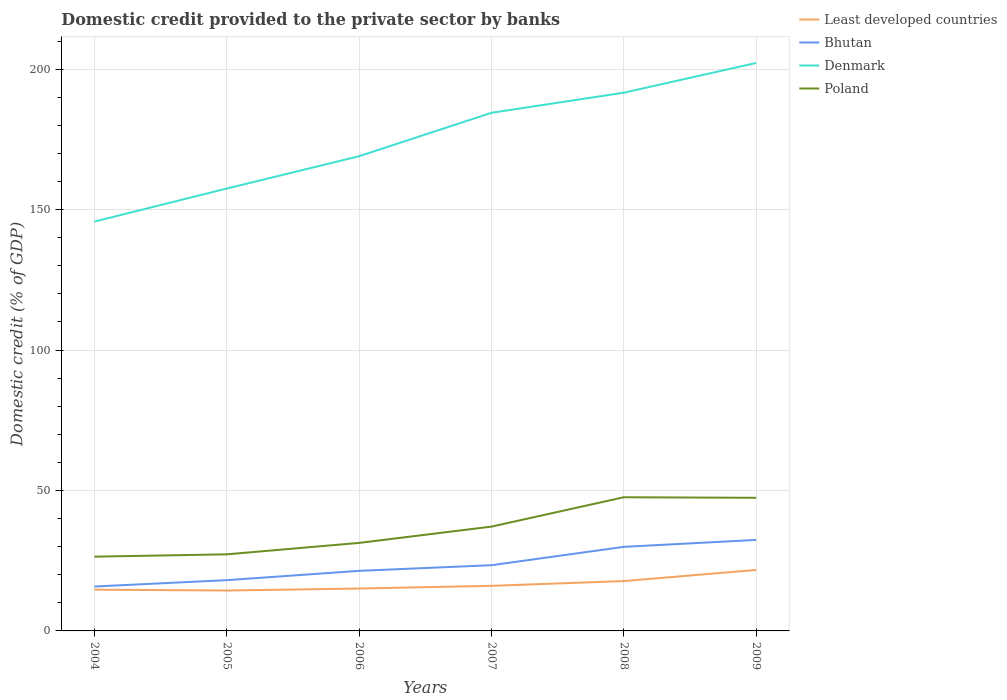Does the line corresponding to Least developed countries intersect with the line corresponding to Bhutan?
Keep it short and to the point. No. Is the number of lines equal to the number of legend labels?
Your answer should be very brief. Yes. Across all years, what is the maximum domestic credit provided to the private sector by banks in Bhutan?
Provide a succinct answer. 15.81. What is the total domestic credit provided to the private sector by banks in Poland in the graph?
Ensure brevity in your answer.  -10.25. What is the difference between the highest and the second highest domestic credit provided to the private sector by banks in Bhutan?
Keep it short and to the point. 16.58. What is the difference between the highest and the lowest domestic credit provided to the private sector by banks in Denmark?
Your answer should be compact. 3. How many years are there in the graph?
Provide a short and direct response. 6. What is the difference between two consecutive major ticks on the Y-axis?
Make the answer very short. 50. Does the graph contain any zero values?
Offer a very short reply. No. How are the legend labels stacked?
Keep it short and to the point. Vertical. What is the title of the graph?
Keep it short and to the point. Domestic credit provided to the private sector by banks. Does "Fragile and conflict affected situations" appear as one of the legend labels in the graph?
Ensure brevity in your answer.  No. What is the label or title of the X-axis?
Offer a very short reply. Years. What is the label or title of the Y-axis?
Give a very brief answer. Domestic credit (% of GDP). What is the Domestic credit (% of GDP) in Least developed countries in 2004?
Make the answer very short. 14.69. What is the Domestic credit (% of GDP) of Bhutan in 2004?
Your answer should be compact. 15.81. What is the Domestic credit (% of GDP) of Denmark in 2004?
Provide a succinct answer. 145.72. What is the Domestic credit (% of GDP) in Poland in 2004?
Offer a terse response. 26.44. What is the Domestic credit (% of GDP) in Least developed countries in 2005?
Give a very brief answer. 14.38. What is the Domestic credit (% of GDP) of Bhutan in 2005?
Your response must be concise. 18.07. What is the Domestic credit (% of GDP) in Denmark in 2005?
Provide a succinct answer. 157.49. What is the Domestic credit (% of GDP) in Poland in 2005?
Offer a very short reply. 27.27. What is the Domestic credit (% of GDP) of Least developed countries in 2006?
Your response must be concise. 15.1. What is the Domestic credit (% of GDP) in Bhutan in 2006?
Your answer should be compact. 21.39. What is the Domestic credit (% of GDP) of Denmark in 2006?
Provide a succinct answer. 169. What is the Domestic credit (% of GDP) in Poland in 2006?
Keep it short and to the point. 31.33. What is the Domestic credit (% of GDP) of Least developed countries in 2007?
Your answer should be very brief. 16.05. What is the Domestic credit (% of GDP) of Bhutan in 2007?
Keep it short and to the point. 23.4. What is the Domestic credit (% of GDP) of Denmark in 2007?
Your answer should be compact. 184.45. What is the Domestic credit (% of GDP) in Poland in 2007?
Your answer should be compact. 37.14. What is the Domestic credit (% of GDP) in Least developed countries in 2008?
Provide a succinct answer. 17.75. What is the Domestic credit (% of GDP) in Bhutan in 2008?
Keep it short and to the point. 29.93. What is the Domestic credit (% of GDP) in Denmark in 2008?
Your answer should be compact. 191.61. What is the Domestic credit (% of GDP) in Poland in 2008?
Your answer should be compact. 47.59. What is the Domestic credit (% of GDP) in Least developed countries in 2009?
Your response must be concise. 21.71. What is the Domestic credit (% of GDP) in Bhutan in 2009?
Your answer should be compact. 32.39. What is the Domestic credit (% of GDP) of Denmark in 2009?
Keep it short and to the point. 202.19. What is the Domestic credit (% of GDP) of Poland in 2009?
Your answer should be very brief. 47.39. Across all years, what is the maximum Domestic credit (% of GDP) of Least developed countries?
Offer a terse response. 21.71. Across all years, what is the maximum Domestic credit (% of GDP) in Bhutan?
Your response must be concise. 32.39. Across all years, what is the maximum Domestic credit (% of GDP) of Denmark?
Your response must be concise. 202.19. Across all years, what is the maximum Domestic credit (% of GDP) of Poland?
Give a very brief answer. 47.59. Across all years, what is the minimum Domestic credit (% of GDP) of Least developed countries?
Provide a succinct answer. 14.38. Across all years, what is the minimum Domestic credit (% of GDP) of Bhutan?
Ensure brevity in your answer.  15.81. Across all years, what is the minimum Domestic credit (% of GDP) of Denmark?
Give a very brief answer. 145.72. Across all years, what is the minimum Domestic credit (% of GDP) of Poland?
Your answer should be very brief. 26.44. What is the total Domestic credit (% of GDP) of Least developed countries in the graph?
Keep it short and to the point. 99.68. What is the total Domestic credit (% of GDP) in Bhutan in the graph?
Provide a short and direct response. 140.99. What is the total Domestic credit (% of GDP) in Denmark in the graph?
Your answer should be very brief. 1050.45. What is the total Domestic credit (% of GDP) of Poland in the graph?
Your answer should be very brief. 217.15. What is the difference between the Domestic credit (% of GDP) in Least developed countries in 2004 and that in 2005?
Make the answer very short. 0.31. What is the difference between the Domestic credit (% of GDP) in Bhutan in 2004 and that in 2005?
Provide a succinct answer. -2.26. What is the difference between the Domestic credit (% of GDP) of Denmark in 2004 and that in 2005?
Offer a terse response. -11.77. What is the difference between the Domestic credit (% of GDP) of Poland in 2004 and that in 2005?
Make the answer very short. -0.83. What is the difference between the Domestic credit (% of GDP) in Least developed countries in 2004 and that in 2006?
Your answer should be very brief. -0.41. What is the difference between the Domestic credit (% of GDP) in Bhutan in 2004 and that in 2006?
Your answer should be very brief. -5.57. What is the difference between the Domestic credit (% of GDP) in Denmark in 2004 and that in 2006?
Offer a very short reply. -23.28. What is the difference between the Domestic credit (% of GDP) in Poland in 2004 and that in 2006?
Offer a terse response. -4.9. What is the difference between the Domestic credit (% of GDP) of Least developed countries in 2004 and that in 2007?
Provide a succinct answer. -1.36. What is the difference between the Domestic credit (% of GDP) of Bhutan in 2004 and that in 2007?
Your answer should be very brief. -7.58. What is the difference between the Domestic credit (% of GDP) of Denmark in 2004 and that in 2007?
Your response must be concise. -38.73. What is the difference between the Domestic credit (% of GDP) in Poland in 2004 and that in 2007?
Provide a succinct answer. -10.7. What is the difference between the Domestic credit (% of GDP) in Least developed countries in 2004 and that in 2008?
Your response must be concise. -3.05. What is the difference between the Domestic credit (% of GDP) in Bhutan in 2004 and that in 2008?
Make the answer very short. -14.12. What is the difference between the Domestic credit (% of GDP) of Denmark in 2004 and that in 2008?
Ensure brevity in your answer.  -45.88. What is the difference between the Domestic credit (% of GDP) in Poland in 2004 and that in 2008?
Keep it short and to the point. -21.15. What is the difference between the Domestic credit (% of GDP) of Least developed countries in 2004 and that in 2009?
Give a very brief answer. -7.02. What is the difference between the Domestic credit (% of GDP) in Bhutan in 2004 and that in 2009?
Keep it short and to the point. -16.58. What is the difference between the Domestic credit (% of GDP) in Denmark in 2004 and that in 2009?
Provide a short and direct response. -56.47. What is the difference between the Domestic credit (% of GDP) of Poland in 2004 and that in 2009?
Offer a terse response. -20.95. What is the difference between the Domestic credit (% of GDP) of Least developed countries in 2005 and that in 2006?
Your response must be concise. -0.71. What is the difference between the Domestic credit (% of GDP) in Bhutan in 2005 and that in 2006?
Your response must be concise. -3.32. What is the difference between the Domestic credit (% of GDP) in Denmark in 2005 and that in 2006?
Provide a succinct answer. -11.51. What is the difference between the Domestic credit (% of GDP) in Poland in 2005 and that in 2006?
Give a very brief answer. -4.07. What is the difference between the Domestic credit (% of GDP) in Least developed countries in 2005 and that in 2007?
Ensure brevity in your answer.  -1.67. What is the difference between the Domestic credit (% of GDP) in Bhutan in 2005 and that in 2007?
Provide a succinct answer. -5.33. What is the difference between the Domestic credit (% of GDP) of Denmark in 2005 and that in 2007?
Keep it short and to the point. -26.96. What is the difference between the Domestic credit (% of GDP) of Poland in 2005 and that in 2007?
Ensure brevity in your answer.  -9.87. What is the difference between the Domestic credit (% of GDP) in Least developed countries in 2005 and that in 2008?
Give a very brief answer. -3.36. What is the difference between the Domestic credit (% of GDP) of Bhutan in 2005 and that in 2008?
Make the answer very short. -11.86. What is the difference between the Domestic credit (% of GDP) of Denmark in 2005 and that in 2008?
Provide a succinct answer. -34.12. What is the difference between the Domestic credit (% of GDP) of Poland in 2005 and that in 2008?
Your response must be concise. -20.32. What is the difference between the Domestic credit (% of GDP) in Least developed countries in 2005 and that in 2009?
Offer a very short reply. -7.33. What is the difference between the Domestic credit (% of GDP) of Bhutan in 2005 and that in 2009?
Give a very brief answer. -14.33. What is the difference between the Domestic credit (% of GDP) of Denmark in 2005 and that in 2009?
Your response must be concise. -44.7. What is the difference between the Domestic credit (% of GDP) in Poland in 2005 and that in 2009?
Keep it short and to the point. -20.12. What is the difference between the Domestic credit (% of GDP) of Least developed countries in 2006 and that in 2007?
Your response must be concise. -0.95. What is the difference between the Domestic credit (% of GDP) in Bhutan in 2006 and that in 2007?
Provide a succinct answer. -2.01. What is the difference between the Domestic credit (% of GDP) of Denmark in 2006 and that in 2007?
Offer a terse response. -15.45. What is the difference between the Domestic credit (% of GDP) of Poland in 2006 and that in 2007?
Provide a short and direct response. -5.8. What is the difference between the Domestic credit (% of GDP) of Least developed countries in 2006 and that in 2008?
Keep it short and to the point. -2.65. What is the difference between the Domestic credit (% of GDP) in Bhutan in 2006 and that in 2008?
Your response must be concise. -8.55. What is the difference between the Domestic credit (% of GDP) of Denmark in 2006 and that in 2008?
Ensure brevity in your answer.  -22.61. What is the difference between the Domestic credit (% of GDP) in Poland in 2006 and that in 2008?
Ensure brevity in your answer.  -16.25. What is the difference between the Domestic credit (% of GDP) in Least developed countries in 2006 and that in 2009?
Keep it short and to the point. -6.61. What is the difference between the Domestic credit (% of GDP) of Bhutan in 2006 and that in 2009?
Provide a succinct answer. -11.01. What is the difference between the Domestic credit (% of GDP) of Denmark in 2006 and that in 2009?
Your response must be concise. -33.19. What is the difference between the Domestic credit (% of GDP) in Poland in 2006 and that in 2009?
Provide a short and direct response. -16.05. What is the difference between the Domestic credit (% of GDP) in Least developed countries in 2007 and that in 2008?
Provide a succinct answer. -1.7. What is the difference between the Domestic credit (% of GDP) of Bhutan in 2007 and that in 2008?
Offer a terse response. -6.53. What is the difference between the Domestic credit (% of GDP) in Denmark in 2007 and that in 2008?
Provide a short and direct response. -7.16. What is the difference between the Domestic credit (% of GDP) in Poland in 2007 and that in 2008?
Your answer should be compact. -10.45. What is the difference between the Domestic credit (% of GDP) of Least developed countries in 2007 and that in 2009?
Keep it short and to the point. -5.66. What is the difference between the Domestic credit (% of GDP) of Bhutan in 2007 and that in 2009?
Keep it short and to the point. -9. What is the difference between the Domestic credit (% of GDP) in Denmark in 2007 and that in 2009?
Provide a short and direct response. -17.74. What is the difference between the Domestic credit (% of GDP) of Poland in 2007 and that in 2009?
Give a very brief answer. -10.25. What is the difference between the Domestic credit (% of GDP) in Least developed countries in 2008 and that in 2009?
Provide a short and direct response. -3.96. What is the difference between the Domestic credit (% of GDP) of Bhutan in 2008 and that in 2009?
Your response must be concise. -2.46. What is the difference between the Domestic credit (% of GDP) of Denmark in 2008 and that in 2009?
Provide a succinct answer. -10.58. What is the difference between the Domestic credit (% of GDP) of Poland in 2008 and that in 2009?
Keep it short and to the point. 0.2. What is the difference between the Domestic credit (% of GDP) of Least developed countries in 2004 and the Domestic credit (% of GDP) of Bhutan in 2005?
Your answer should be compact. -3.38. What is the difference between the Domestic credit (% of GDP) of Least developed countries in 2004 and the Domestic credit (% of GDP) of Denmark in 2005?
Offer a very short reply. -142.8. What is the difference between the Domestic credit (% of GDP) of Least developed countries in 2004 and the Domestic credit (% of GDP) of Poland in 2005?
Your answer should be very brief. -12.57. What is the difference between the Domestic credit (% of GDP) in Bhutan in 2004 and the Domestic credit (% of GDP) in Denmark in 2005?
Offer a terse response. -141.68. What is the difference between the Domestic credit (% of GDP) in Bhutan in 2004 and the Domestic credit (% of GDP) in Poland in 2005?
Your response must be concise. -11.45. What is the difference between the Domestic credit (% of GDP) in Denmark in 2004 and the Domestic credit (% of GDP) in Poland in 2005?
Your response must be concise. 118.46. What is the difference between the Domestic credit (% of GDP) in Least developed countries in 2004 and the Domestic credit (% of GDP) in Bhutan in 2006?
Make the answer very short. -6.69. What is the difference between the Domestic credit (% of GDP) in Least developed countries in 2004 and the Domestic credit (% of GDP) in Denmark in 2006?
Provide a short and direct response. -154.31. What is the difference between the Domestic credit (% of GDP) in Least developed countries in 2004 and the Domestic credit (% of GDP) in Poland in 2006?
Your answer should be compact. -16.64. What is the difference between the Domestic credit (% of GDP) in Bhutan in 2004 and the Domestic credit (% of GDP) in Denmark in 2006?
Ensure brevity in your answer.  -153.19. What is the difference between the Domestic credit (% of GDP) of Bhutan in 2004 and the Domestic credit (% of GDP) of Poland in 2006?
Provide a succinct answer. -15.52. What is the difference between the Domestic credit (% of GDP) of Denmark in 2004 and the Domestic credit (% of GDP) of Poland in 2006?
Your response must be concise. 114.39. What is the difference between the Domestic credit (% of GDP) in Least developed countries in 2004 and the Domestic credit (% of GDP) in Bhutan in 2007?
Provide a succinct answer. -8.71. What is the difference between the Domestic credit (% of GDP) of Least developed countries in 2004 and the Domestic credit (% of GDP) of Denmark in 2007?
Provide a short and direct response. -169.76. What is the difference between the Domestic credit (% of GDP) of Least developed countries in 2004 and the Domestic credit (% of GDP) of Poland in 2007?
Keep it short and to the point. -22.45. What is the difference between the Domestic credit (% of GDP) in Bhutan in 2004 and the Domestic credit (% of GDP) in Denmark in 2007?
Ensure brevity in your answer.  -168.63. What is the difference between the Domestic credit (% of GDP) in Bhutan in 2004 and the Domestic credit (% of GDP) in Poland in 2007?
Offer a terse response. -21.32. What is the difference between the Domestic credit (% of GDP) of Denmark in 2004 and the Domestic credit (% of GDP) of Poland in 2007?
Keep it short and to the point. 108.58. What is the difference between the Domestic credit (% of GDP) of Least developed countries in 2004 and the Domestic credit (% of GDP) of Bhutan in 2008?
Make the answer very short. -15.24. What is the difference between the Domestic credit (% of GDP) of Least developed countries in 2004 and the Domestic credit (% of GDP) of Denmark in 2008?
Your answer should be very brief. -176.91. What is the difference between the Domestic credit (% of GDP) in Least developed countries in 2004 and the Domestic credit (% of GDP) in Poland in 2008?
Offer a very short reply. -32.9. What is the difference between the Domestic credit (% of GDP) of Bhutan in 2004 and the Domestic credit (% of GDP) of Denmark in 2008?
Your response must be concise. -175.79. What is the difference between the Domestic credit (% of GDP) of Bhutan in 2004 and the Domestic credit (% of GDP) of Poland in 2008?
Keep it short and to the point. -31.77. What is the difference between the Domestic credit (% of GDP) in Denmark in 2004 and the Domestic credit (% of GDP) in Poland in 2008?
Offer a very short reply. 98.13. What is the difference between the Domestic credit (% of GDP) in Least developed countries in 2004 and the Domestic credit (% of GDP) in Bhutan in 2009?
Ensure brevity in your answer.  -17.7. What is the difference between the Domestic credit (% of GDP) in Least developed countries in 2004 and the Domestic credit (% of GDP) in Denmark in 2009?
Offer a terse response. -187.5. What is the difference between the Domestic credit (% of GDP) of Least developed countries in 2004 and the Domestic credit (% of GDP) of Poland in 2009?
Ensure brevity in your answer.  -32.7. What is the difference between the Domestic credit (% of GDP) of Bhutan in 2004 and the Domestic credit (% of GDP) of Denmark in 2009?
Your answer should be very brief. -186.38. What is the difference between the Domestic credit (% of GDP) in Bhutan in 2004 and the Domestic credit (% of GDP) in Poland in 2009?
Offer a terse response. -31.58. What is the difference between the Domestic credit (% of GDP) of Denmark in 2004 and the Domestic credit (% of GDP) of Poland in 2009?
Make the answer very short. 98.33. What is the difference between the Domestic credit (% of GDP) of Least developed countries in 2005 and the Domestic credit (% of GDP) of Bhutan in 2006?
Your answer should be compact. -7. What is the difference between the Domestic credit (% of GDP) in Least developed countries in 2005 and the Domestic credit (% of GDP) in Denmark in 2006?
Offer a terse response. -154.62. What is the difference between the Domestic credit (% of GDP) of Least developed countries in 2005 and the Domestic credit (% of GDP) of Poland in 2006?
Give a very brief answer. -16.95. What is the difference between the Domestic credit (% of GDP) in Bhutan in 2005 and the Domestic credit (% of GDP) in Denmark in 2006?
Your answer should be compact. -150.93. What is the difference between the Domestic credit (% of GDP) of Bhutan in 2005 and the Domestic credit (% of GDP) of Poland in 2006?
Keep it short and to the point. -13.27. What is the difference between the Domestic credit (% of GDP) of Denmark in 2005 and the Domestic credit (% of GDP) of Poland in 2006?
Keep it short and to the point. 126.15. What is the difference between the Domestic credit (% of GDP) of Least developed countries in 2005 and the Domestic credit (% of GDP) of Bhutan in 2007?
Your answer should be compact. -9.01. What is the difference between the Domestic credit (% of GDP) in Least developed countries in 2005 and the Domestic credit (% of GDP) in Denmark in 2007?
Your answer should be compact. -170.06. What is the difference between the Domestic credit (% of GDP) in Least developed countries in 2005 and the Domestic credit (% of GDP) in Poland in 2007?
Your answer should be compact. -22.75. What is the difference between the Domestic credit (% of GDP) in Bhutan in 2005 and the Domestic credit (% of GDP) in Denmark in 2007?
Give a very brief answer. -166.38. What is the difference between the Domestic credit (% of GDP) of Bhutan in 2005 and the Domestic credit (% of GDP) of Poland in 2007?
Your answer should be compact. -19.07. What is the difference between the Domestic credit (% of GDP) of Denmark in 2005 and the Domestic credit (% of GDP) of Poland in 2007?
Your response must be concise. 120.35. What is the difference between the Domestic credit (% of GDP) in Least developed countries in 2005 and the Domestic credit (% of GDP) in Bhutan in 2008?
Provide a short and direct response. -15.55. What is the difference between the Domestic credit (% of GDP) in Least developed countries in 2005 and the Domestic credit (% of GDP) in Denmark in 2008?
Your response must be concise. -177.22. What is the difference between the Domestic credit (% of GDP) in Least developed countries in 2005 and the Domestic credit (% of GDP) in Poland in 2008?
Offer a terse response. -33.2. What is the difference between the Domestic credit (% of GDP) of Bhutan in 2005 and the Domestic credit (% of GDP) of Denmark in 2008?
Make the answer very short. -173.54. What is the difference between the Domestic credit (% of GDP) in Bhutan in 2005 and the Domestic credit (% of GDP) in Poland in 2008?
Offer a terse response. -29.52. What is the difference between the Domestic credit (% of GDP) in Denmark in 2005 and the Domestic credit (% of GDP) in Poland in 2008?
Your response must be concise. 109.9. What is the difference between the Domestic credit (% of GDP) in Least developed countries in 2005 and the Domestic credit (% of GDP) in Bhutan in 2009?
Give a very brief answer. -18.01. What is the difference between the Domestic credit (% of GDP) in Least developed countries in 2005 and the Domestic credit (% of GDP) in Denmark in 2009?
Ensure brevity in your answer.  -187.81. What is the difference between the Domestic credit (% of GDP) of Least developed countries in 2005 and the Domestic credit (% of GDP) of Poland in 2009?
Offer a terse response. -33. What is the difference between the Domestic credit (% of GDP) of Bhutan in 2005 and the Domestic credit (% of GDP) of Denmark in 2009?
Make the answer very short. -184.12. What is the difference between the Domestic credit (% of GDP) of Bhutan in 2005 and the Domestic credit (% of GDP) of Poland in 2009?
Your answer should be very brief. -29.32. What is the difference between the Domestic credit (% of GDP) in Denmark in 2005 and the Domestic credit (% of GDP) in Poland in 2009?
Ensure brevity in your answer.  110.1. What is the difference between the Domestic credit (% of GDP) in Least developed countries in 2006 and the Domestic credit (% of GDP) in Bhutan in 2007?
Your answer should be very brief. -8.3. What is the difference between the Domestic credit (% of GDP) in Least developed countries in 2006 and the Domestic credit (% of GDP) in Denmark in 2007?
Your response must be concise. -169.35. What is the difference between the Domestic credit (% of GDP) of Least developed countries in 2006 and the Domestic credit (% of GDP) of Poland in 2007?
Provide a short and direct response. -22.04. What is the difference between the Domestic credit (% of GDP) in Bhutan in 2006 and the Domestic credit (% of GDP) in Denmark in 2007?
Offer a terse response. -163.06. What is the difference between the Domestic credit (% of GDP) in Bhutan in 2006 and the Domestic credit (% of GDP) in Poland in 2007?
Ensure brevity in your answer.  -15.75. What is the difference between the Domestic credit (% of GDP) in Denmark in 2006 and the Domestic credit (% of GDP) in Poland in 2007?
Provide a succinct answer. 131.86. What is the difference between the Domestic credit (% of GDP) in Least developed countries in 2006 and the Domestic credit (% of GDP) in Bhutan in 2008?
Your answer should be very brief. -14.83. What is the difference between the Domestic credit (% of GDP) in Least developed countries in 2006 and the Domestic credit (% of GDP) in Denmark in 2008?
Offer a very short reply. -176.51. What is the difference between the Domestic credit (% of GDP) in Least developed countries in 2006 and the Domestic credit (% of GDP) in Poland in 2008?
Offer a very short reply. -32.49. What is the difference between the Domestic credit (% of GDP) in Bhutan in 2006 and the Domestic credit (% of GDP) in Denmark in 2008?
Keep it short and to the point. -170.22. What is the difference between the Domestic credit (% of GDP) of Bhutan in 2006 and the Domestic credit (% of GDP) of Poland in 2008?
Your answer should be very brief. -26.2. What is the difference between the Domestic credit (% of GDP) of Denmark in 2006 and the Domestic credit (% of GDP) of Poland in 2008?
Provide a succinct answer. 121.41. What is the difference between the Domestic credit (% of GDP) in Least developed countries in 2006 and the Domestic credit (% of GDP) in Bhutan in 2009?
Offer a very short reply. -17.3. What is the difference between the Domestic credit (% of GDP) in Least developed countries in 2006 and the Domestic credit (% of GDP) in Denmark in 2009?
Make the answer very short. -187.09. What is the difference between the Domestic credit (% of GDP) of Least developed countries in 2006 and the Domestic credit (% of GDP) of Poland in 2009?
Offer a terse response. -32.29. What is the difference between the Domestic credit (% of GDP) of Bhutan in 2006 and the Domestic credit (% of GDP) of Denmark in 2009?
Provide a short and direct response. -180.8. What is the difference between the Domestic credit (% of GDP) of Bhutan in 2006 and the Domestic credit (% of GDP) of Poland in 2009?
Give a very brief answer. -26. What is the difference between the Domestic credit (% of GDP) of Denmark in 2006 and the Domestic credit (% of GDP) of Poland in 2009?
Provide a short and direct response. 121.61. What is the difference between the Domestic credit (% of GDP) in Least developed countries in 2007 and the Domestic credit (% of GDP) in Bhutan in 2008?
Offer a terse response. -13.88. What is the difference between the Domestic credit (% of GDP) of Least developed countries in 2007 and the Domestic credit (% of GDP) of Denmark in 2008?
Ensure brevity in your answer.  -175.56. What is the difference between the Domestic credit (% of GDP) of Least developed countries in 2007 and the Domestic credit (% of GDP) of Poland in 2008?
Offer a terse response. -31.54. What is the difference between the Domestic credit (% of GDP) in Bhutan in 2007 and the Domestic credit (% of GDP) in Denmark in 2008?
Provide a short and direct response. -168.21. What is the difference between the Domestic credit (% of GDP) in Bhutan in 2007 and the Domestic credit (% of GDP) in Poland in 2008?
Provide a succinct answer. -24.19. What is the difference between the Domestic credit (% of GDP) of Denmark in 2007 and the Domestic credit (% of GDP) of Poland in 2008?
Your answer should be very brief. 136.86. What is the difference between the Domestic credit (% of GDP) in Least developed countries in 2007 and the Domestic credit (% of GDP) in Bhutan in 2009?
Provide a succinct answer. -16.34. What is the difference between the Domestic credit (% of GDP) of Least developed countries in 2007 and the Domestic credit (% of GDP) of Denmark in 2009?
Provide a short and direct response. -186.14. What is the difference between the Domestic credit (% of GDP) of Least developed countries in 2007 and the Domestic credit (% of GDP) of Poland in 2009?
Keep it short and to the point. -31.34. What is the difference between the Domestic credit (% of GDP) in Bhutan in 2007 and the Domestic credit (% of GDP) in Denmark in 2009?
Give a very brief answer. -178.79. What is the difference between the Domestic credit (% of GDP) of Bhutan in 2007 and the Domestic credit (% of GDP) of Poland in 2009?
Your answer should be very brief. -23.99. What is the difference between the Domestic credit (% of GDP) of Denmark in 2007 and the Domestic credit (% of GDP) of Poland in 2009?
Provide a succinct answer. 137.06. What is the difference between the Domestic credit (% of GDP) in Least developed countries in 2008 and the Domestic credit (% of GDP) in Bhutan in 2009?
Provide a succinct answer. -14.65. What is the difference between the Domestic credit (% of GDP) of Least developed countries in 2008 and the Domestic credit (% of GDP) of Denmark in 2009?
Keep it short and to the point. -184.44. What is the difference between the Domestic credit (% of GDP) in Least developed countries in 2008 and the Domestic credit (% of GDP) in Poland in 2009?
Make the answer very short. -29.64. What is the difference between the Domestic credit (% of GDP) in Bhutan in 2008 and the Domestic credit (% of GDP) in Denmark in 2009?
Ensure brevity in your answer.  -172.26. What is the difference between the Domestic credit (% of GDP) of Bhutan in 2008 and the Domestic credit (% of GDP) of Poland in 2009?
Ensure brevity in your answer.  -17.46. What is the difference between the Domestic credit (% of GDP) of Denmark in 2008 and the Domestic credit (% of GDP) of Poland in 2009?
Your answer should be compact. 144.22. What is the average Domestic credit (% of GDP) in Least developed countries per year?
Your answer should be compact. 16.61. What is the average Domestic credit (% of GDP) of Bhutan per year?
Give a very brief answer. 23.5. What is the average Domestic credit (% of GDP) of Denmark per year?
Make the answer very short. 175.08. What is the average Domestic credit (% of GDP) of Poland per year?
Ensure brevity in your answer.  36.19. In the year 2004, what is the difference between the Domestic credit (% of GDP) in Least developed countries and Domestic credit (% of GDP) in Bhutan?
Ensure brevity in your answer.  -1.12. In the year 2004, what is the difference between the Domestic credit (% of GDP) of Least developed countries and Domestic credit (% of GDP) of Denmark?
Give a very brief answer. -131.03. In the year 2004, what is the difference between the Domestic credit (% of GDP) of Least developed countries and Domestic credit (% of GDP) of Poland?
Your answer should be compact. -11.75. In the year 2004, what is the difference between the Domestic credit (% of GDP) of Bhutan and Domestic credit (% of GDP) of Denmark?
Your response must be concise. -129.91. In the year 2004, what is the difference between the Domestic credit (% of GDP) of Bhutan and Domestic credit (% of GDP) of Poland?
Make the answer very short. -10.62. In the year 2004, what is the difference between the Domestic credit (% of GDP) of Denmark and Domestic credit (% of GDP) of Poland?
Your answer should be compact. 119.29. In the year 2005, what is the difference between the Domestic credit (% of GDP) in Least developed countries and Domestic credit (% of GDP) in Bhutan?
Provide a short and direct response. -3.69. In the year 2005, what is the difference between the Domestic credit (% of GDP) of Least developed countries and Domestic credit (% of GDP) of Denmark?
Offer a very short reply. -143.11. In the year 2005, what is the difference between the Domestic credit (% of GDP) of Least developed countries and Domestic credit (% of GDP) of Poland?
Provide a short and direct response. -12.88. In the year 2005, what is the difference between the Domestic credit (% of GDP) of Bhutan and Domestic credit (% of GDP) of Denmark?
Your answer should be compact. -139.42. In the year 2005, what is the difference between the Domestic credit (% of GDP) of Bhutan and Domestic credit (% of GDP) of Poland?
Your answer should be very brief. -9.2. In the year 2005, what is the difference between the Domestic credit (% of GDP) in Denmark and Domestic credit (% of GDP) in Poland?
Your answer should be compact. 130.22. In the year 2006, what is the difference between the Domestic credit (% of GDP) of Least developed countries and Domestic credit (% of GDP) of Bhutan?
Offer a very short reply. -6.29. In the year 2006, what is the difference between the Domestic credit (% of GDP) of Least developed countries and Domestic credit (% of GDP) of Denmark?
Offer a terse response. -153.9. In the year 2006, what is the difference between the Domestic credit (% of GDP) of Least developed countries and Domestic credit (% of GDP) of Poland?
Keep it short and to the point. -16.24. In the year 2006, what is the difference between the Domestic credit (% of GDP) in Bhutan and Domestic credit (% of GDP) in Denmark?
Give a very brief answer. -147.61. In the year 2006, what is the difference between the Domestic credit (% of GDP) of Bhutan and Domestic credit (% of GDP) of Poland?
Keep it short and to the point. -9.95. In the year 2006, what is the difference between the Domestic credit (% of GDP) of Denmark and Domestic credit (% of GDP) of Poland?
Keep it short and to the point. 137.66. In the year 2007, what is the difference between the Domestic credit (% of GDP) in Least developed countries and Domestic credit (% of GDP) in Bhutan?
Offer a terse response. -7.35. In the year 2007, what is the difference between the Domestic credit (% of GDP) of Least developed countries and Domestic credit (% of GDP) of Denmark?
Offer a terse response. -168.4. In the year 2007, what is the difference between the Domestic credit (% of GDP) in Least developed countries and Domestic credit (% of GDP) in Poland?
Ensure brevity in your answer.  -21.09. In the year 2007, what is the difference between the Domestic credit (% of GDP) of Bhutan and Domestic credit (% of GDP) of Denmark?
Offer a terse response. -161.05. In the year 2007, what is the difference between the Domestic credit (% of GDP) in Bhutan and Domestic credit (% of GDP) in Poland?
Provide a short and direct response. -13.74. In the year 2007, what is the difference between the Domestic credit (% of GDP) in Denmark and Domestic credit (% of GDP) in Poland?
Your answer should be very brief. 147.31. In the year 2008, what is the difference between the Domestic credit (% of GDP) of Least developed countries and Domestic credit (% of GDP) of Bhutan?
Provide a short and direct response. -12.19. In the year 2008, what is the difference between the Domestic credit (% of GDP) of Least developed countries and Domestic credit (% of GDP) of Denmark?
Your answer should be very brief. -173.86. In the year 2008, what is the difference between the Domestic credit (% of GDP) in Least developed countries and Domestic credit (% of GDP) in Poland?
Your answer should be very brief. -29.84. In the year 2008, what is the difference between the Domestic credit (% of GDP) in Bhutan and Domestic credit (% of GDP) in Denmark?
Provide a succinct answer. -161.68. In the year 2008, what is the difference between the Domestic credit (% of GDP) of Bhutan and Domestic credit (% of GDP) of Poland?
Provide a short and direct response. -17.66. In the year 2008, what is the difference between the Domestic credit (% of GDP) in Denmark and Domestic credit (% of GDP) in Poland?
Your response must be concise. 144.02. In the year 2009, what is the difference between the Domestic credit (% of GDP) in Least developed countries and Domestic credit (% of GDP) in Bhutan?
Keep it short and to the point. -10.68. In the year 2009, what is the difference between the Domestic credit (% of GDP) in Least developed countries and Domestic credit (% of GDP) in Denmark?
Provide a short and direct response. -180.48. In the year 2009, what is the difference between the Domestic credit (% of GDP) of Least developed countries and Domestic credit (% of GDP) of Poland?
Offer a very short reply. -25.68. In the year 2009, what is the difference between the Domestic credit (% of GDP) in Bhutan and Domestic credit (% of GDP) in Denmark?
Your response must be concise. -169.79. In the year 2009, what is the difference between the Domestic credit (% of GDP) in Bhutan and Domestic credit (% of GDP) in Poland?
Offer a very short reply. -14.99. In the year 2009, what is the difference between the Domestic credit (% of GDP) of Denmark and Domestic credit (% of GDP) of Poland?
Your response must be concise. 154.8. What is the ratio of the Domestic credit (% of GDP) of Least developed countries in 2004 to that in 2005?
Offer a terse response. 1.02. What is the ratio of the Domestic credit (% of GDP) in Bhutan in 2004 to that in 2005?
Your answer should be very brief. 0.88. What is the ratio of the Domestic credit (% of GDP) of Denmark in 2004 to that in 2005?
Offer a terse response. 0.93. What is the ratio of the Domestic credit (% of GDP) in Poland in 2004 to that in 2005?
Provide a short and direct response. 0.97. What is the ratio of the Domestic credit (% of GDP) of Least developed countries in 2004 to that in 2006?
Your answer should be compact. 0.97. What is the ratio of the Domestic credit (% of GDP) of Bhutan in 2004 to that in 2006?
Your answer should be very brief. 0.74. What is the ratio of the Domestic credit (% of GDP) of Denmark in 2004 to that in 2006?
Provide a short and direct response. 0.86. What is the ratio of the Domestic credit (% of GDP) in Poland in 2004 to that in 2006?
Your response must be concise. 0.84. What is the ratio of the Domestic credit (% of GDP) of Least developed countries in 2004 to that in 2007?
Offer a terse response. 0.92. What is the ratio of the Domestic credit (% of GDP) in Bhutan in 2004 to that in 2007?
Your answer should be very brief. 0.68. What is the ratio of the Domestic credit (% of GDP) of Denmark in 2004 to that in 2007?
Provide a succinct answer. 0.79. What is the ratio of the Domestic credit (% of GDP) in Poland in 2004 to that in 2007?
Ensure brevity in your answer.  0.71. What is the ratio of the Domestic credit (% of GDP) in Least developed countries in 2004 to that in 2008?
Keep it short and to the point. 0.83. What is the ratio of the Domestic credit (% of GDP) of Bhutan in 2004 to that in 2008?
Provide a succinct answer. 0.53. What is the ratio of the Domestic credit (% of GDP) in Denmark in 2004 to that in 2008?
Your response must be concise. 0.76. What is the ratio of the Domestic credit (% of GDP) of Poland in 2004 to that in 2008?
Provide a succinct answer. 0.56. What is the ratio of the Domestic credit (% of GDP) in Least developed countries in 2004 to that in 2009?
Provide a short and direct response. 0.68. What is the ratio of the Domestic credit (% of GDP) of Bhutan in 2004 to that in 2009?
Give a very brief answer. 0.49. What is the ratio of the Domestic credit (% of GDP) in Denmark in 2004 to that in 2009?
Ensure brevity in your answer.  0.72. What is the ratio of the Domestic credit (% of GDP) in Poland in 2004 to that in 2009?
Your response must be concise. 0.56. What is the ratio of the Domestic credit (% of GDP) of Least developed countries in 2005 to that in 2006?
Make the answer very short. 0.95. What is the ratio of the Domestic credit (% of GDP) in Bhutan in 2005 to that in 2006?
Provide a short and direct response. 0.84. What is the ratio of the Domestic credit (% of GDP) of Denmark in 2005 to that in 2006?
Provide a short and direct response. 0.93. What is the ratio of the Domestic credit (% of GDP) of Poland in 2005 to that in 2006?
Provide a succinct answer. 0.87. What is the ratio of the Domestic credit (% of GDP) in Least developed countries in 2005 to that in 2007?
Provide a short and direct response. 0.9. What is the ratio of the Domestic credit (% of GDP) in Bhutan in 2005 to that in 2007?
Your answer should be very brief. 0.77. What is the ratio of the Domestic credit (% of GDP) of Denmark in 2005 to that in 2007?
Offer a terse response. 0.85. What is the ratio of the Domestic credit (% of GDP) of Poland in 2005 to that in 2007?
Offer a terse response. 0.73. What is the ratio of the Domestic credit (% of GDP) of Least developed countries in 2005 to that in 2008?
Give a very brief answer. 0.81. What is the ratio of the Domestic credit (% of GDP) of Bhutan in 2005 to that in 2008?
Your response must be concise. 0.6. What is the ratio of the Domestic credit (% of GDP) of Denmark in 2005 to that in 2008?
Offer a very short reply. 0.82. What is the ratio of the Domestic credit (% of GDP) of Poland in 2005 to that in 2008?
Give a very brief answer. 0.57. What is the ratio of the Domestic credit (% of GDP) of Least developed countries in 2005 to that in 2009?
Provide a succinct answer. 0.66. What is the ratio of the Domestic credit (% of GDP) in Bhutan in 2005 to that in 2009?
Give a very brief answer. 0.56. What is the ratio of the Domestic credit (% of GDP) of Denmark in 2005 to that in 2009?
Give a very brief answer. 0.78. What is the ratio of the Domestic credit (% of GDP) in Poland in 2005 to that in 2009?
Provide a succinct answer. 0.58. What is the ratio of the Domestic credit (% of GDP) of Least developed countries in 2006 to that in 2007?
Keep it short and to the point. 0.94. What is the ratio of the Domestic credit (% of GDP) of Bhutan in 2006 to that in 2007?
Your response must be concise. 0.91. What is the ratio of the Domestic credit (% of GDP) of Denmark in 2006 to that in 2007?
Make the answer very short. 0.92. What is the ratio of the Domestic credit (% of GDP) in Poland in 2006 to that in 2007?
Keep it short and to the point. 0.84. What is the ratio of the Domestic credit (% of GDP) in Least developed countries in 2006 to that in 2008?
Give a very brief answer. 0.85. What is the ratio of the Domestic credit (% of GDP) of Bhutan in 2006 to that in 2008?
Make the answer very short. 0.71. What is the ratio of the Domestic credit (% of GDP) in Denmark in 2006 to that in 2008?
Make the answer very short. 0.88. What is the ratio of the Domestic credit (% of GDP) of Poland in 2006 to that in 2008?
Your response must be concise. 0.66. What is the ratio of the Domestic credit (% of GDP) of Least developed countries in 2006 to that in 2009?
Make the answer very short. 0.7. What is the ratio of the Domestic credit (% of GDP) of Bhutan in 2006 to that in 2009?
Keep it short and to the point. 0.66. What is the ratio of the Domestic credit (% of GDP) in Denmark in 2006 to that in 2009?
Provide a succinct answer. 0.84. What is the ratio of the Domestic credit (% of GDP) in Poland in 2006 to that in 2009?
Provide a succinct answer. 0.66. What is the ratio of the Domestic credit (% of GDP) of Least developed countries in 2007 to that in 2008?
Give a very brief answer. 0.9. What is the ratio of the Domestic credit (% of GDP) of Bhutan in 2007 to that in 2008?
Offer a terse response. 0.78. What is the ratio of the Domestic credit (% of GDP) in Denmark in 2007 to that in 2008?
Ensure brevity in your answer.  0.96. What is the ratio of the Domestic credit (% of GDP) in Poland in 2007 to that in 2008?
Ensure brevity in your answer.  0.78. What is the ratio of the Domestic credit (% of GDP) in Least developed countries in 2007 to that in 2009?
Your response must be concise. 0.74. What is the ratio of the Domestic credit (% of GDP) in Bhutan in 2007 to that in 2009?
Make the answer very short. 0.72. What is the ratio of the Domestic credit (% of GDP) of Denmark in 2007 to that in 2009?
Ensure brevity in your answer.  0.91. What is the ratio of the Domestic credit (% of GDP) in Poland in 2007 to that in 2009?
Your answer should be compact. 0.78. What is the ratio of the Domestic credit (% of GDP) in Least developed countries in 2008 to that in 2009?
Your answer should be compact. 0.82. What is the ratio of the Domestic credit (% of GDP) of Bhutan in 2008 to that in 2009?
Ensure brevity in your answer.  0.92. What is the ratio of the Domestic credit (% of GDP) in Denmark in 2008 to that in 2009?
Offer a terse response. 0.95. What is the difference between the highest and the second highest Domestic credit (% of GDP) in Least developed countries?
Keep it short and to the point. 3.96. What is the difference between the highest and the second highest Domestic credit (% of GDP) in Bhutan?
Provide a succinct answer. 2.46. What is the difference between the highest and the second highest Domestic credit (% of GDP) in Denmark?
Make the answer very short. 10.58. What is the difference between the highest and the second highest Domestic credit (% of GDP) of Poland?
Give a very brief answer. 0.2. What is the difference between the highest and the lowest Domestic credit (% of GDP) of Least developed countries?
Make the answer very short. 7.33. What is the difference between the highest and the lowest Domestic credit (% of GDP) in Bhutan?
Offer a very short reply. 16.58. What is the difference between the highest and the lowest Domestic credit (% of GDP) of Denmark?
Provide a short and direct response. 56.47. What is the difference between the highest and the lowest Domestic credit (% of GDP) in Poland?
Your answer should be very brief. 21.15. 